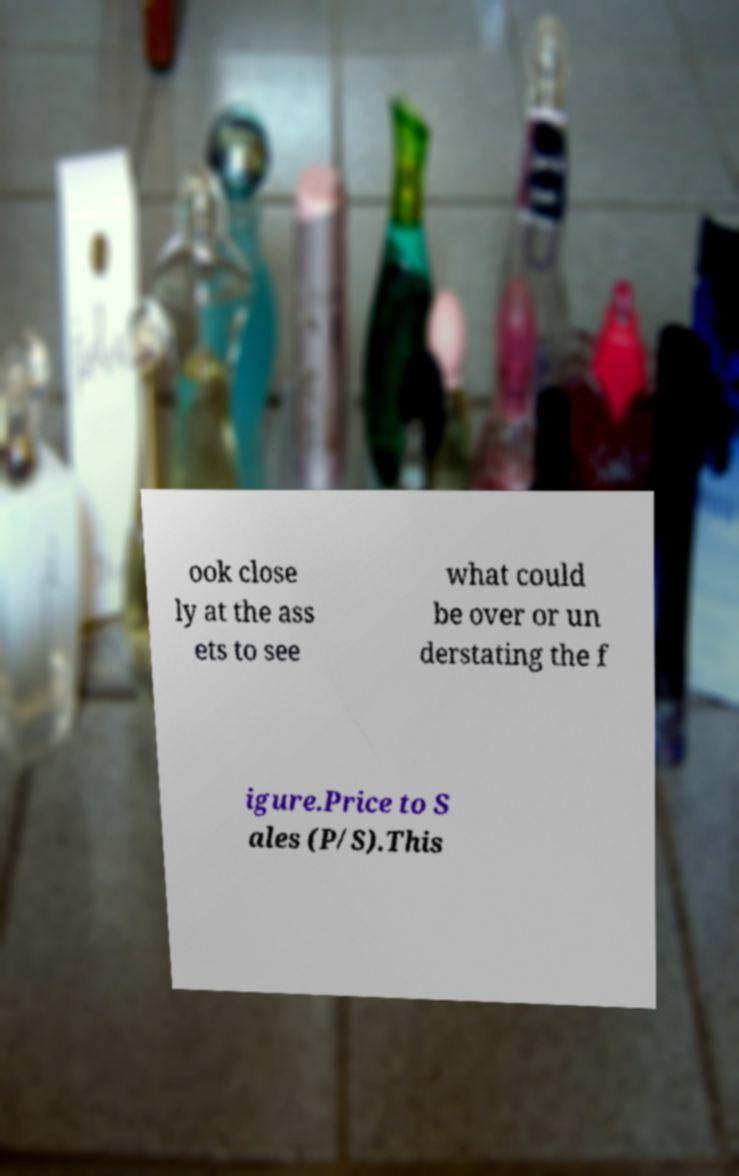Can you accurately transcribe the text from the provided image for me? ook close ly at the ass ets to see what could be over or un derstating the f igure.Price to S ales (P/S).This 